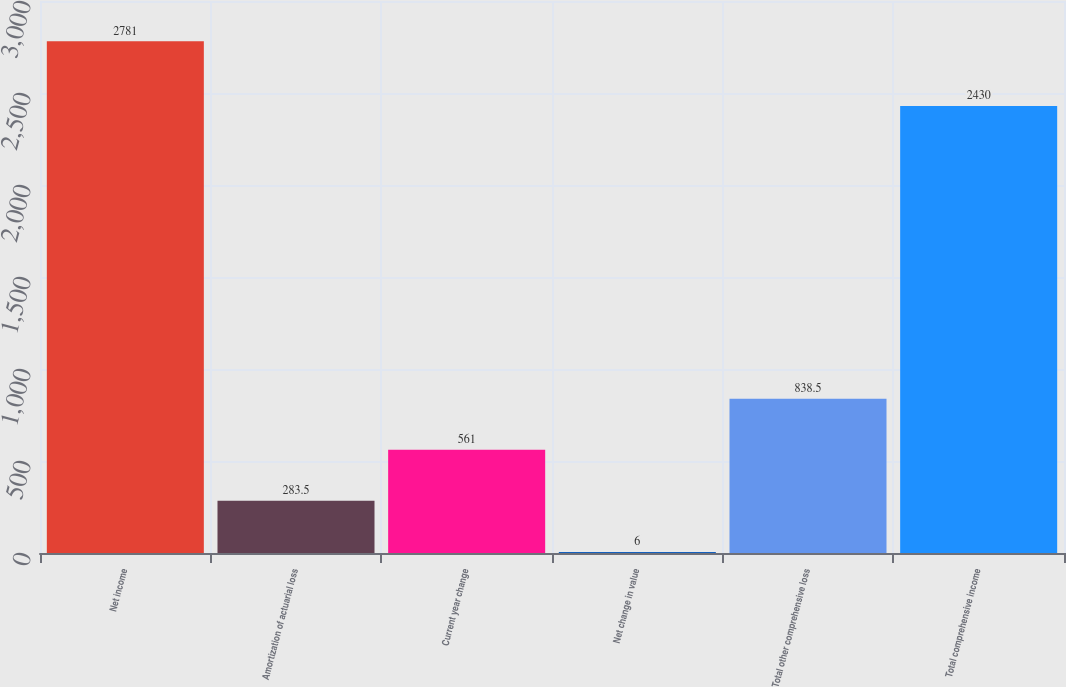Convert chart. <chart><loc_0><loc_0><loc_500><loc_500><bar_chart><fcel>Net income<fcel>Amortization of actuarial loss<fcel>Current year change<fcel>Net change in value<fcel>Total other comprehensive loss<fcel>Total comprehensive income<nl><fcel>2781<fcel>283.5<fcel>561<fcel>6<fcel>838.5<fcel>2430<nl></chart> 